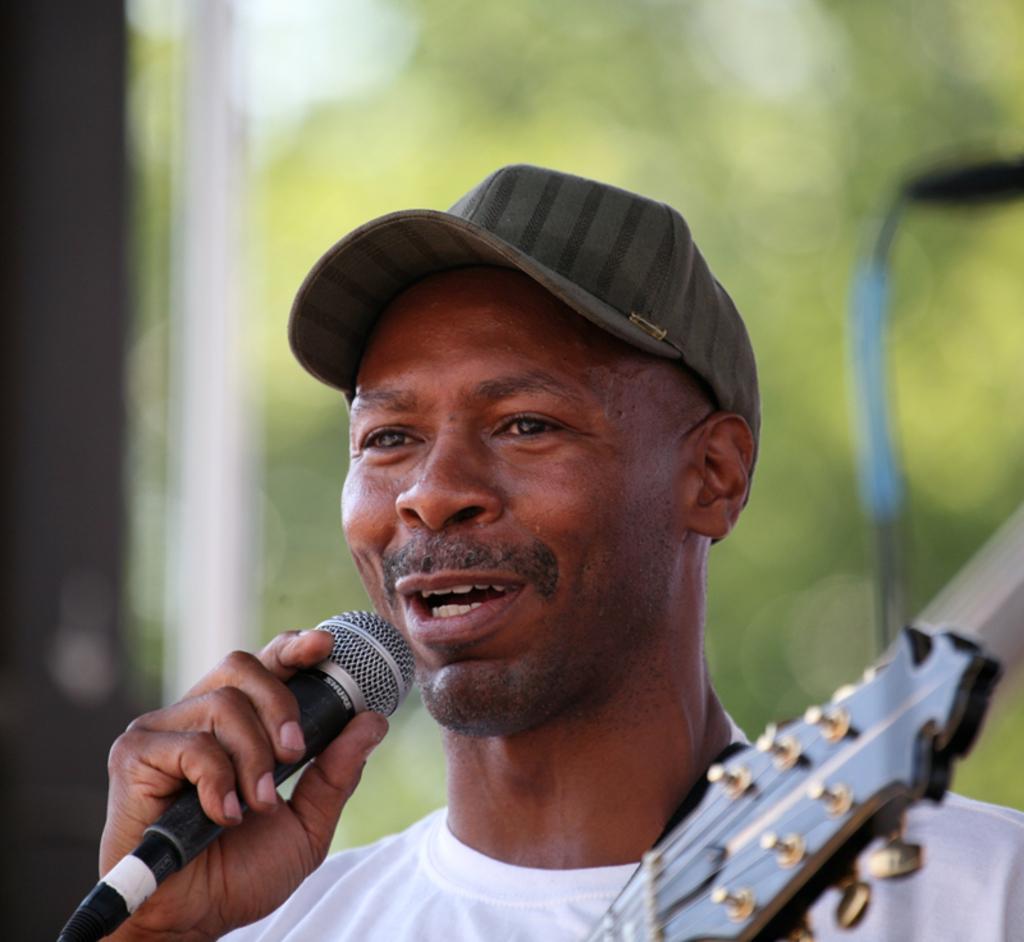Can you describe this image briefly? In the image a person is talking as his mouth is open. He is wearing a cap. He is holding a mic. He is a holding a guitar. In the background there are trees. The background is hazy. 